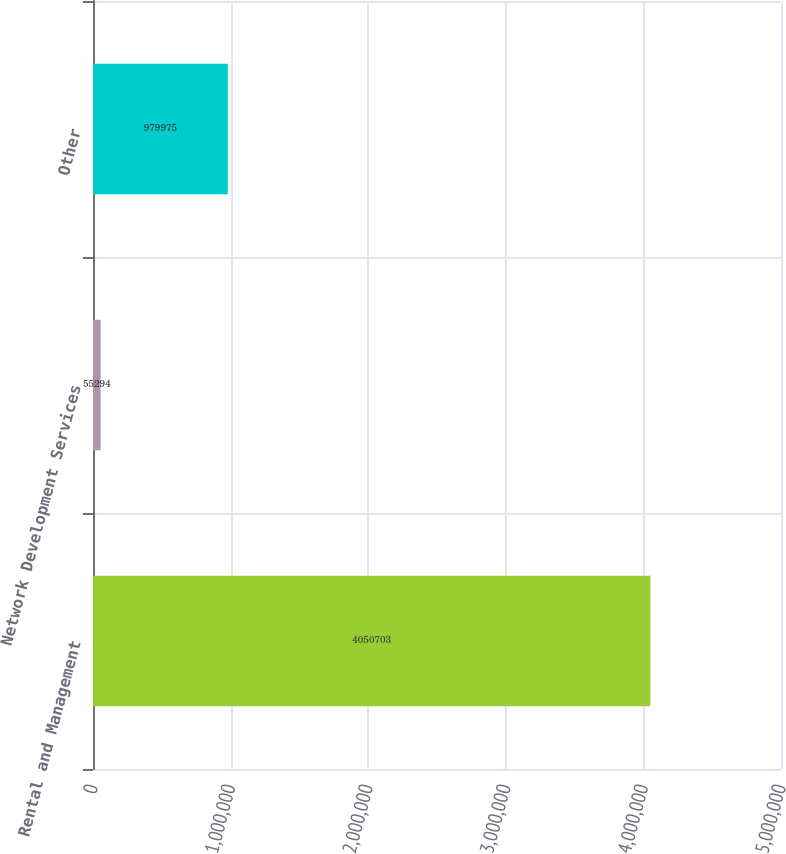<chart> <loc_0><loc_0><loc_500><loc_500><bar_chart><fcel>Rental and Management<fcel>Network Development Services<fcel>Other<nl><fcel>4.0507e+06<fcel>55294<fcel>979975<nl></chart> 